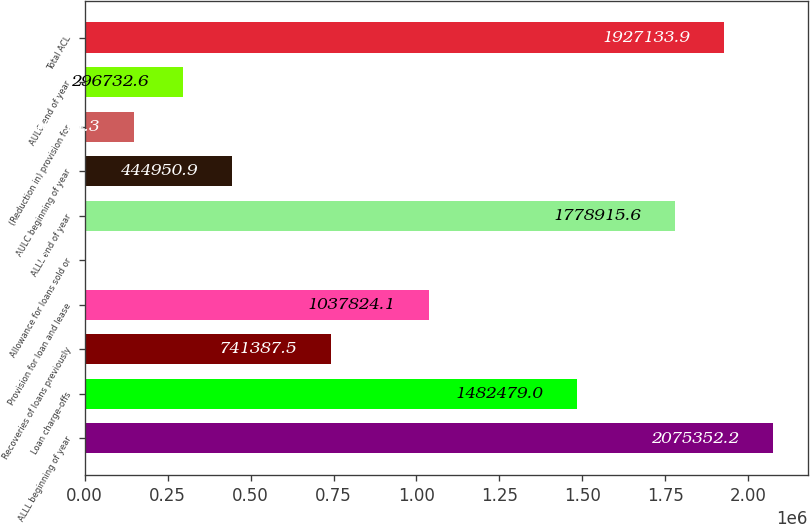<chart> <loc_0><loc_0><loc_500><loc_500><bar_chart><fcel>ALLL beginning of year<fcel>Loan charge-offs<fcel>Recoveries of loans previously<fcel>Provision for loan and lease<fcel>Allowance for loans sold or<fcel>ALLL end of year<fcel>AULC beginning of year<fcel>(Reduction in) provision for<fcel>AULC end of year<fcel>Total ACL<nl><fcel>2.07535e+06<fcel>1.48248e+06<fcel>741388<fcel>1.03782e+06<fcel>296<fcel>1.77892e+06<fcel>444951<fcel>148514<fcel>296733<fcel>1.92713e+06<nl></chart> 